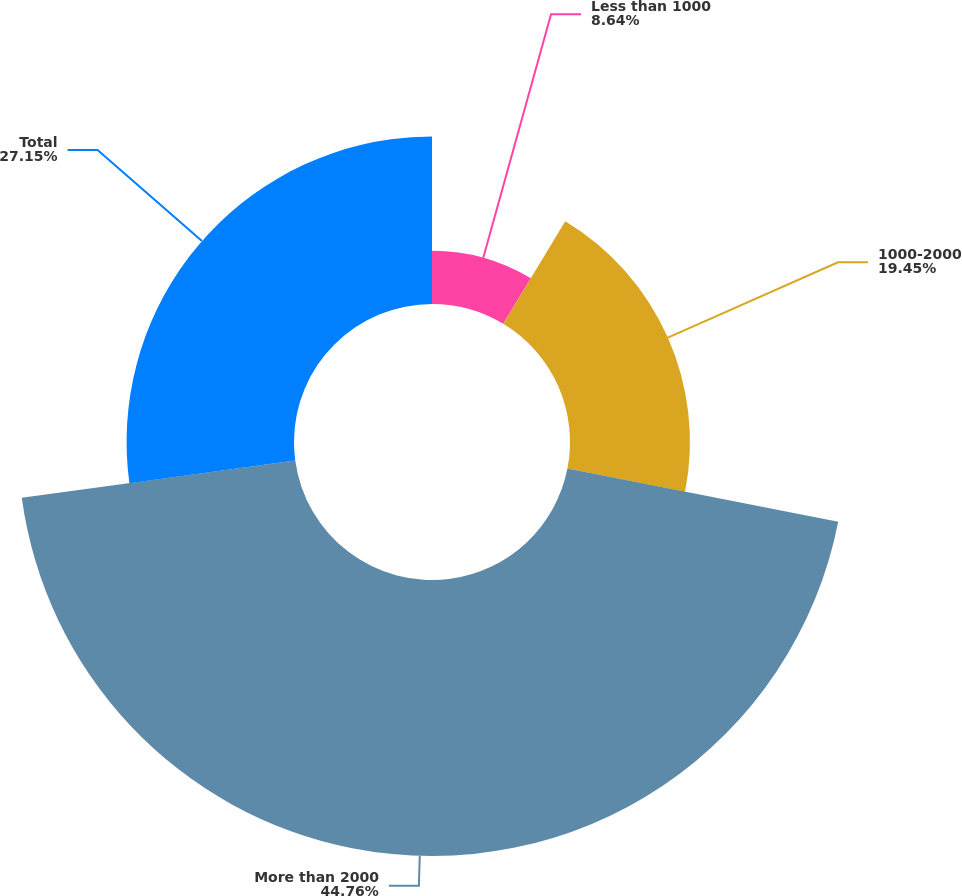<chart> <loc_0><loc_0><loc_500><loc_500><pie_chart><fcel>Less than 1000<fcel>1000-2000<fcel>More than 2000<fcel>Total<nl><fcel>8.64%<fcel>19.45%<fcel>44.76%<fcel>27.15%<nl></chart> 